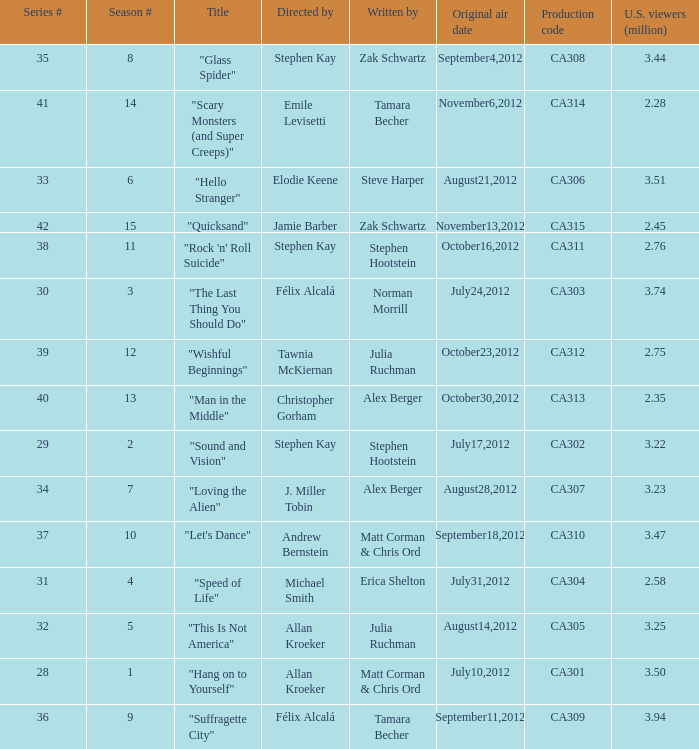Who directed the episode with production code ca311? Stephen Kay. 